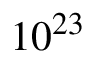<formula> <loc_0><loc_0><loc_500><loc_500>1 0 ^ { 2 3 }</formula> 